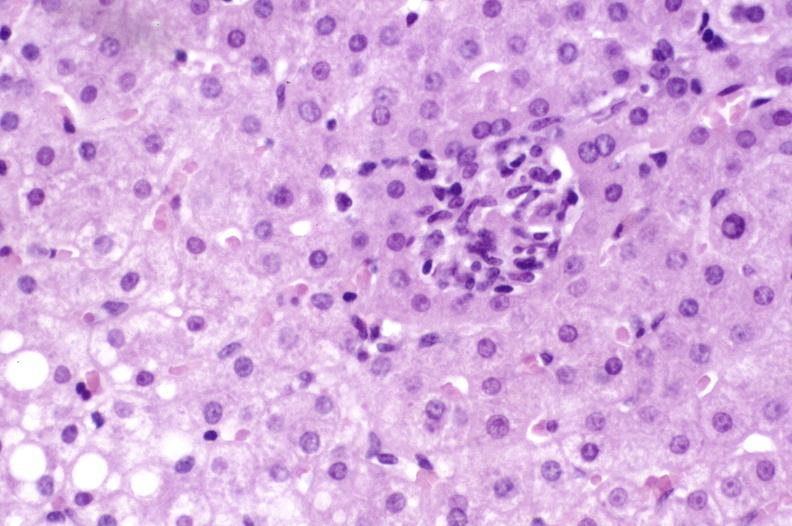does situs inversus show primary biliary cirrhosis?
Answer the question using a single word or phrase. No 